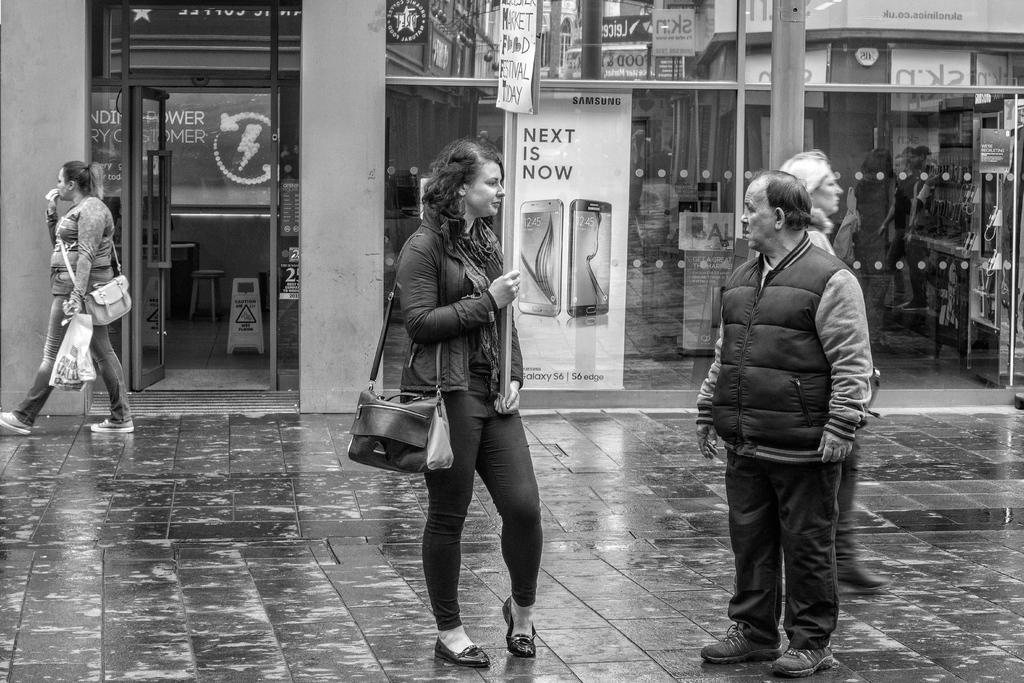In one or two sentences, can you explain what this image depicts? In this black and white image, there are two persons standing and wearing clothes. There is a person on the left side of the image wearing a bag. There is an another person beside the building. 